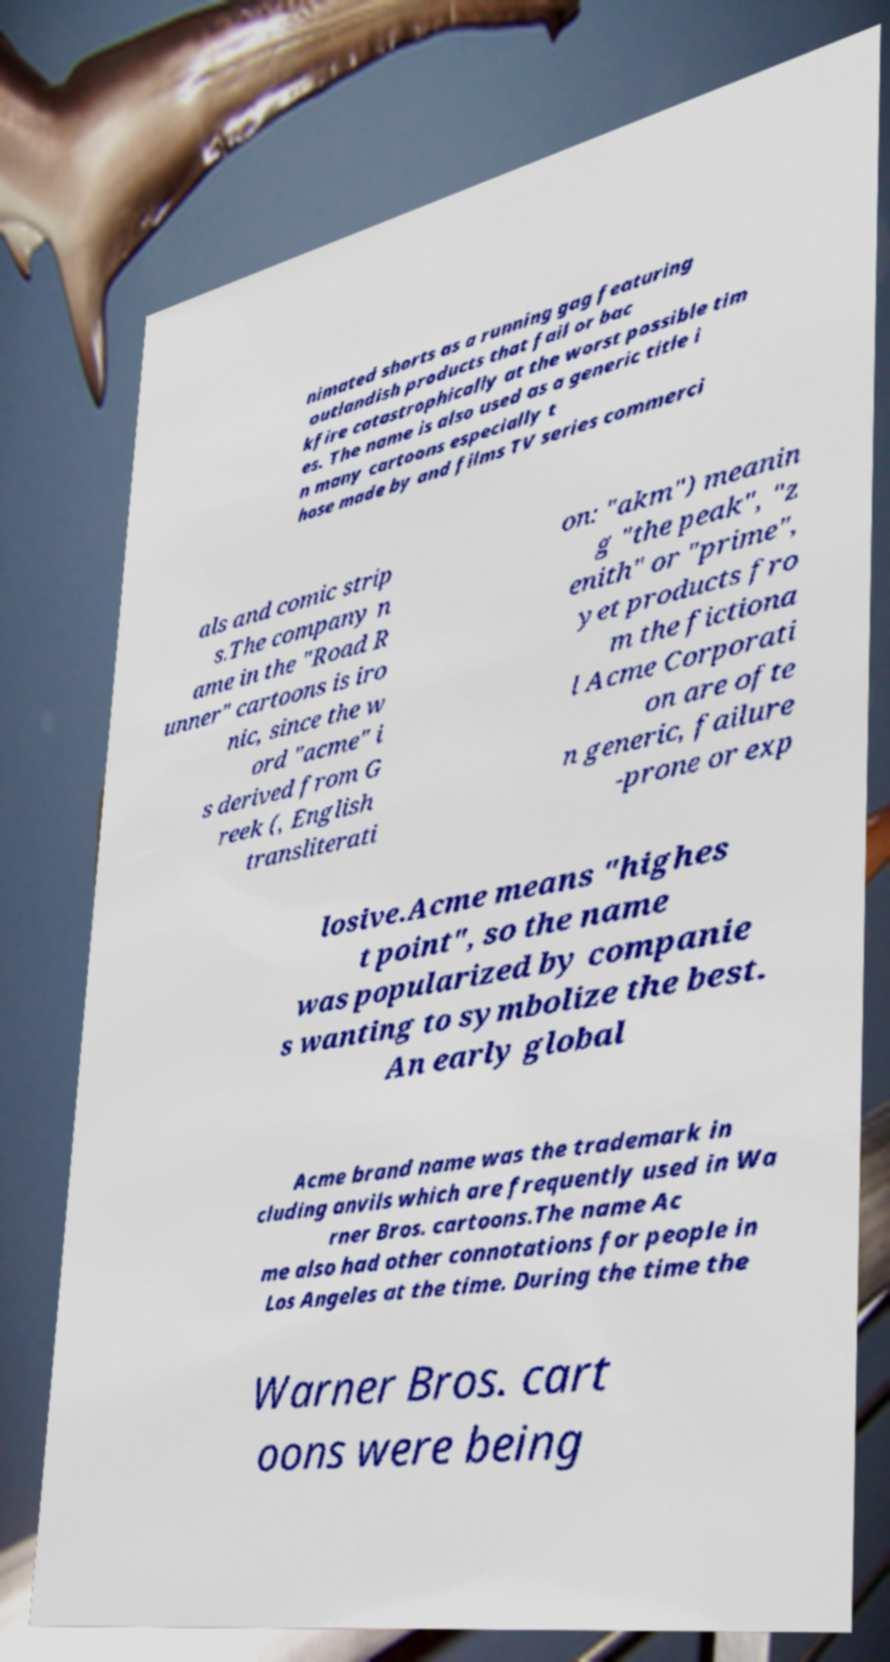Can you accurately transcribe the text from the provided image for me? nimated shorts as a running gag featuring outlandish products that fail or bac kfire catastrophically at the worst possible tim es. The name is also used as a generic title i n many cartoons especially t hose made by and films TV series commerci als and comic strip s.The company n ame in the "Road R unner" cartoons is iro nic, since the w ord "acme" i s derived from G reek (, English transliterati on: "akm") meanin g "the peak", "z enith" or "prime", yet products fro m the fictiona l Acme Corporati on are ofte n generic, failure -prone or exp losive.Acme means "highes t point", so the name was popularized by companie s wanting to symbolize the best. An early global Acme brand name was the trademark in cluding anvils which are frequently used in Wa rner Bros. cartoons.The name Ac me also had other connotations for people in Los Angeles at the time. During the time the Warner Bros. cart oons were being 